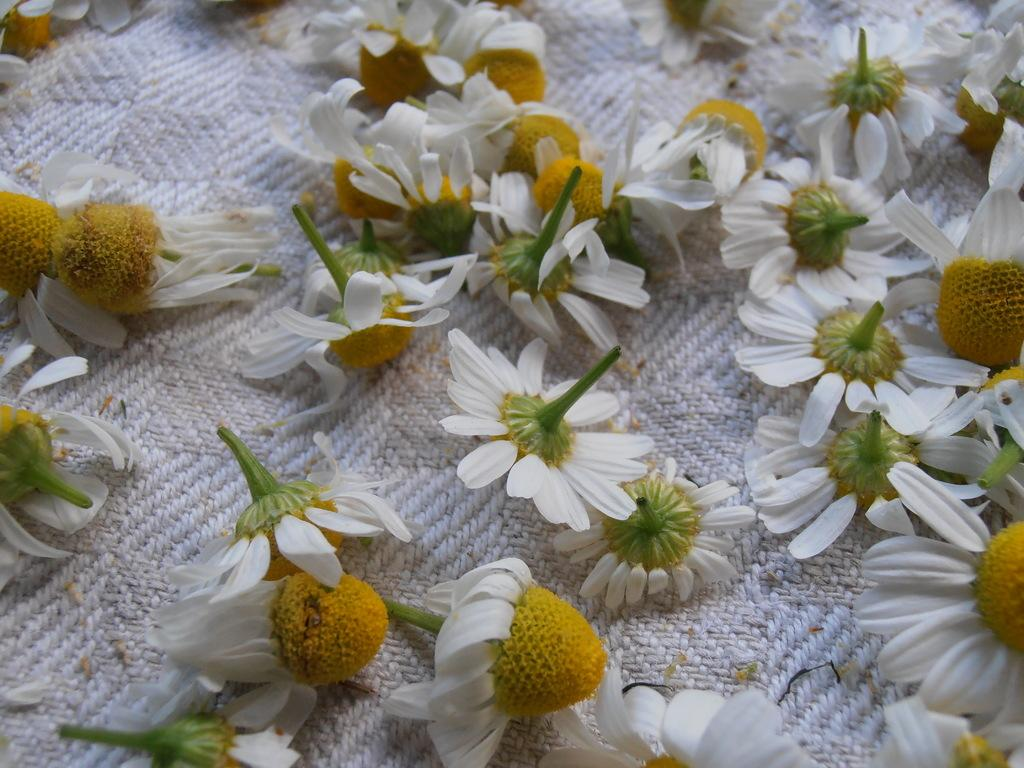What type of plants can be seen in the image? There are flowers in the image. Can you describe the arrangement or setting of the flowers? The flowers might be on a cloth. How many yaks are present in the image? There are no yaks present in the image; it features flowers. What trick can be performed with the flowers in the image? There is no trick being performed with the flowers in the image; they are simply depicted as they are. 